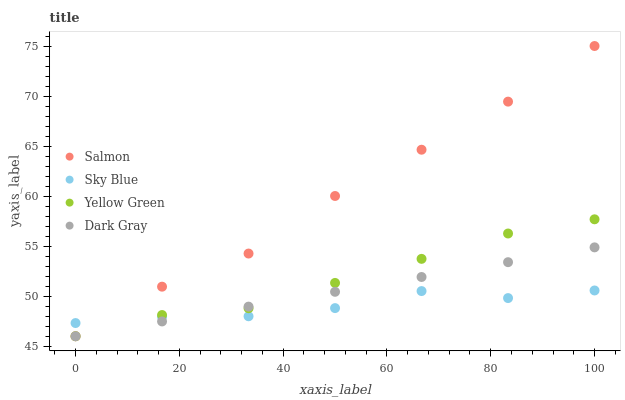Does Sky Blue have the minimum area under the curve?
Answer yes or no. Yes. Does Salmon have the maximum area under the curve?
Answer yes or no. Yes. Does Salmon have the minimum area under the curve?
Answer yes or no. No. Does Sky Blue have the maximum area under the curve?
Answer yes or no. No. Is Dark Gray the smoothest?
Answer yes or no. Yes. Is Salmon the roughest?
Answer yes or no. Yes. Is Sky Blue the smoothest?
Answer yes or no. No. Is Sky Blue the roughest?
Answer yes or no. No. Does Dark Gray have the lowest value?
Answer yes or no. Yes. Does Sky Blue have the lowest value?
Answer yes or no. No. Does Salmon have the highest value?
Answer yes or no. Yes. Does Sky Blue have the highest value?
Answer yes or no. No. Does Salmon intersect Sky Blue?
Answer yes or no. Yes. Is Salmon less than Sky Blue?
Answer yes or no. No. Is Salmon greater than Sky Blue?
Answer yes or no. No. 